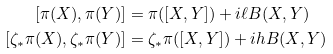<formula> <loc_0><loc_0><loc_500><loc_500>[ \pi ( X ) , \pi ( Y ) ] & = \pi ( [ X , Y ] ) + i \ell B ( X , Y ) \\ [ \zeta _ { * } \pi ( X ) , \zeta _ { * } \pi ( Y ) ] & = \zeta _ { * } \pi ( [ X , Y ] ) + i h B ( X , Y )</formula> 